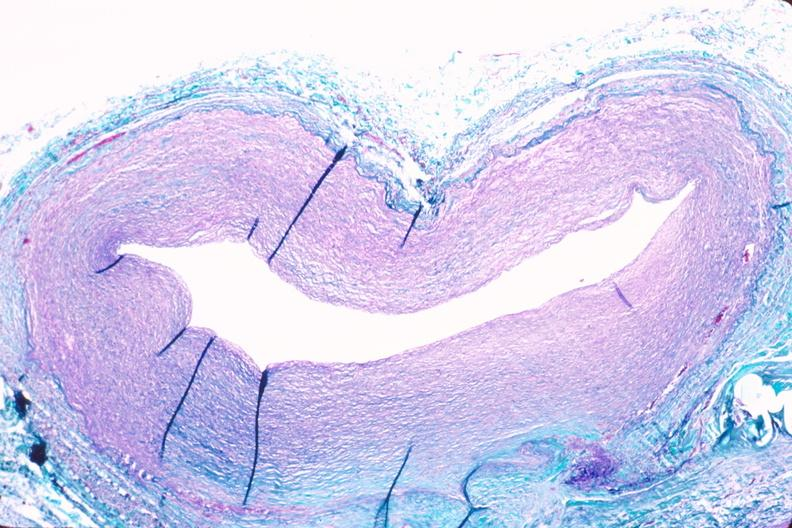s cardiovascular present?
Answer the question using a single word or phrase. Yes 